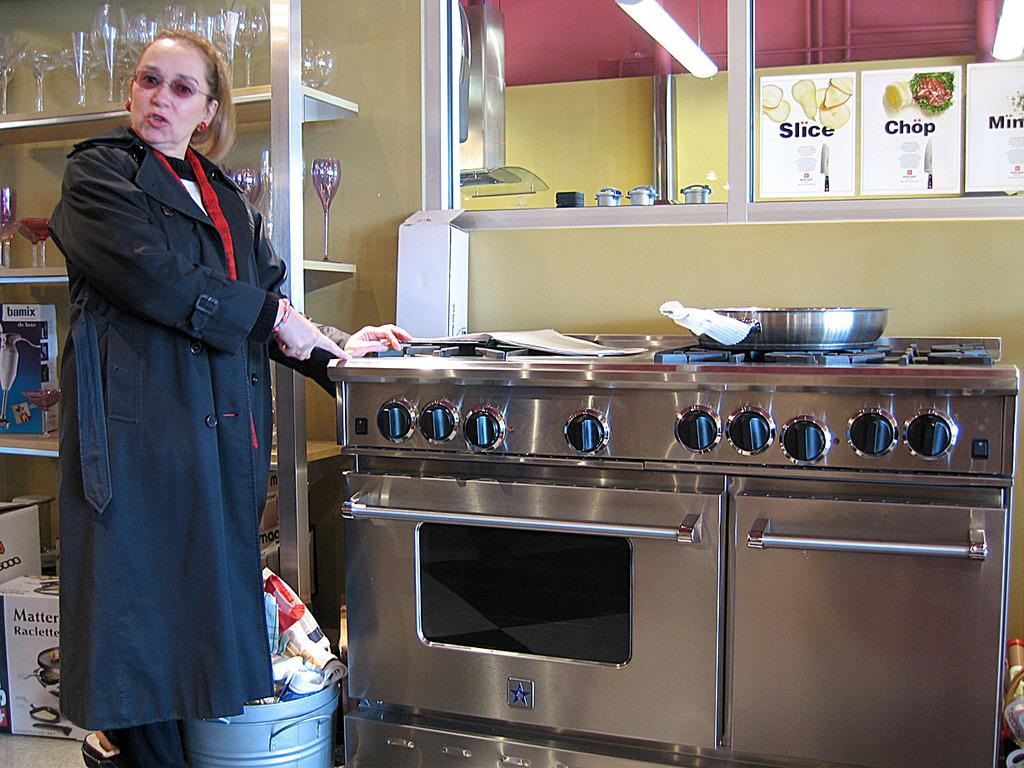<image>
Summarize the visual content of the image. A woman standing by a commercial oven with pictures above it that say slice, chop and mince. 